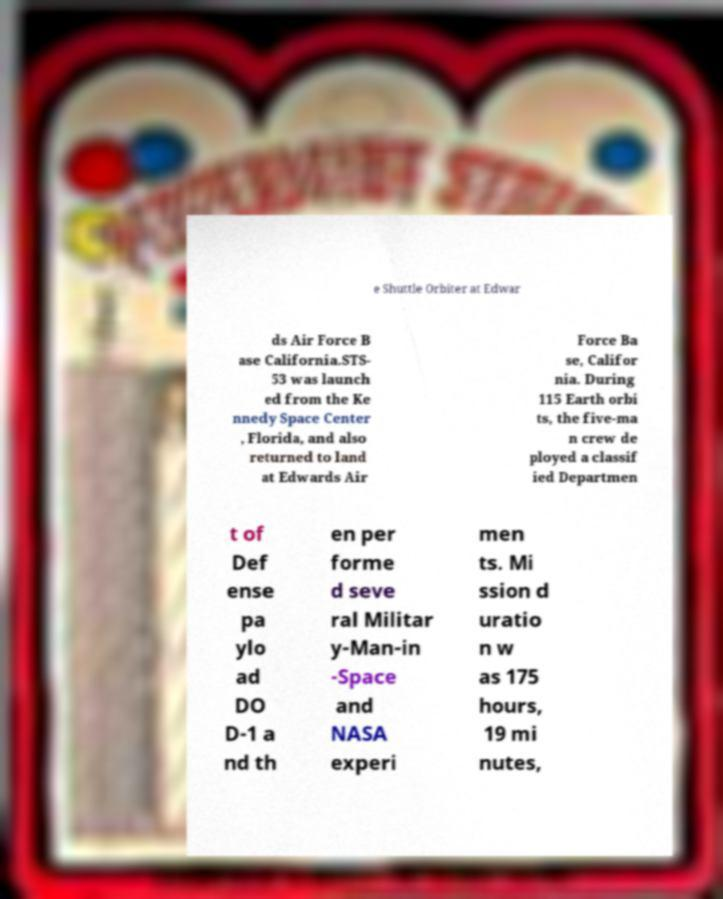Could you assist in decoding the text presented in this image and type it out clearly? e Shuttle Orbiter at Edwar ds Air Force B ase California.STS- 53 was launch ed from the Ke nnedy Space Center , Florida, and also returned to land at Edwards Air Force Ba se, Califor nia. During 115 Earth orbi ts, the five-ma n crew de ployed a classif ied Departmen t of Def ense pa ylo ad DO D-1 a nd th en per forme d seve ral Militar y-Man-in -Space and NASA experi men ts. Mi ssion d uratio n w as 175 hours, 19 mi nutes, 